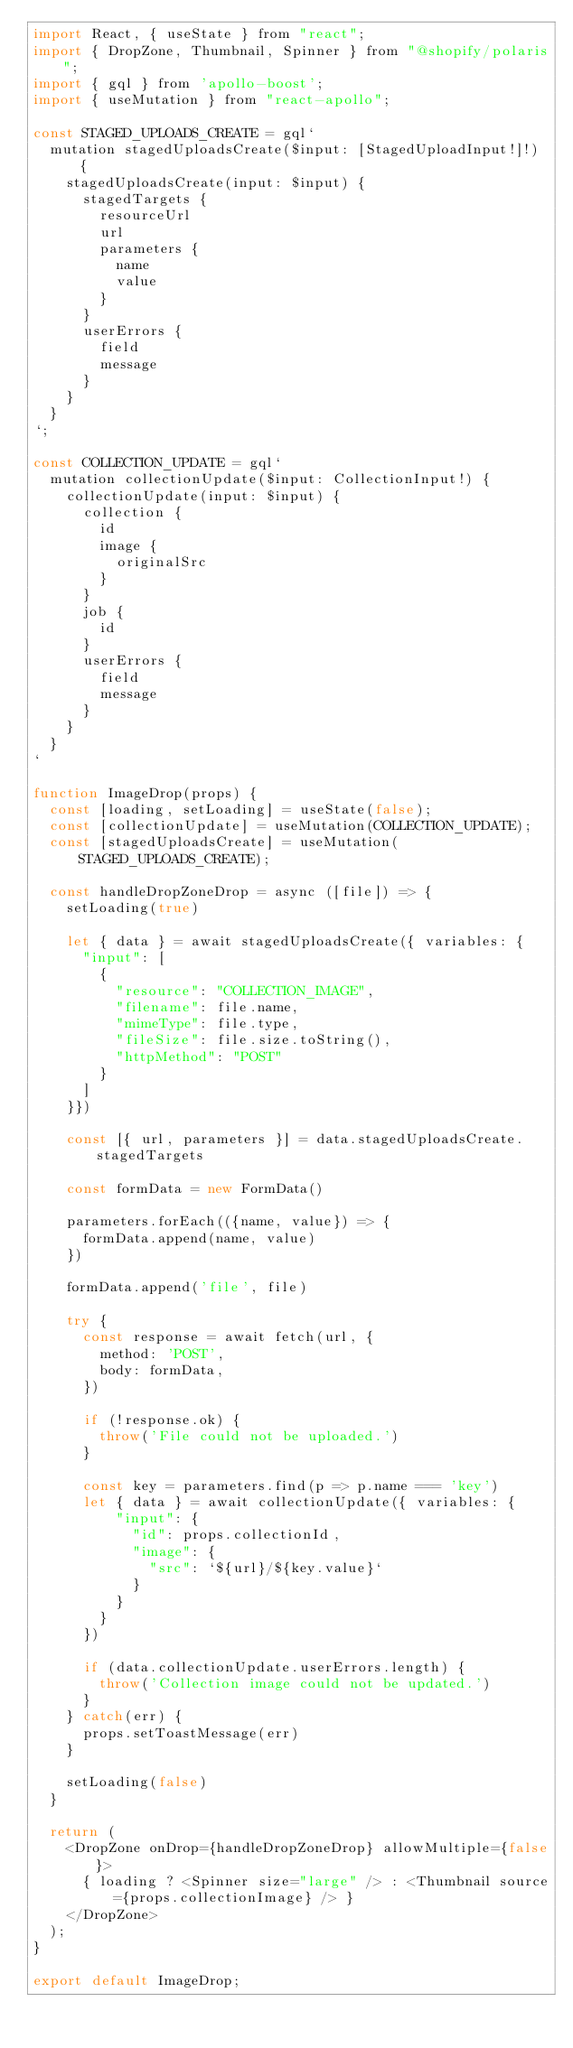Convert code to text. <code><loc_0><loc_0><loc_500><loc_500><_JavaScript_>import React, { useState } from "react";
import { DropZone, Thumbnail, Spinner } from "@shopify/polaris";
import { gql } from 'apollo-boost';
import { useMutation } from "react-apollo";

const STAGED_UPLOADS_CREATE = gql`
  mutation stagedUploadsCreate($input: [StagedUploadInput!]!) {
    stagedUploadsCreate(input: $input) {
      stagedTargets {
        resourceUrl
        url
        parameters {
          name
          value
        }
      }
      userErrors {
        field
        message
      }
    }
  }
`;

const COLLECTION_UPDATE = gql`
  mutation collectionUpdate($input: CollectionInput!) {
    collectionUpdate(input: $input) {
      collection {
        id
        image {
          originalSrc
        }
      }
      job {
        id
      }
      userErrors {
        field
        message
      }
    }
  }
`

function ImageDrop(props) {
  const [loading, setLoading] = useState(false);
  const [collectionUpdate] = useMutation(COLLECTION_UPDATE);
  const [stagedUploadsCreate] = useMutation(STAGED_UPLOADS_CREATE);

  const handleDropZoneDrop = async ([file]) => {
    setLoading(true)

    let { data } = await stagedUploadsCreate({ variables: {
      "input": [
        {
          "resource": "COLLECTION_IMAGE",
          "filename": file.name,
          "mimeType": file.type,
          "fileSize": file.size.toString(),
          "httpMethod": "POST"
        }
      ]
    }})

    const [{ url, parameters }] = data.stagedUploadsCreate.stagedTargets

    const formData = new FormData()

    parameters.forEach(({name, value}) => {
      formData.append(name, value)
    })

    formData.append('file', file)

    try {
      const response = await fetch(url, {
        method: 'POST',
        body: formData,
      })

      if (!response.ok) {
        throw('File could not be uploaded.')
      }

      const key = parameters.find(p => p.name === 'key')
      let { data } = await collectionUpdate({ variables: {
          "input": {
            "id": props.collectionId,
            "image": {
              "src": `${url}/${key.value}`
            }
          }
        }
      })

      if (data.collectionUpdate.userErrors.length) {
        throw('Collection image could not be updated.')
      }
    } catch(err) {
      props.setToastMessage(err)
    }

    setLoading(false)
  }

  return (
    <DropZone onDrop={handleDropZoneDrop} allowMultiple={false}>
      { loading ? <Spinner size="large" /> : <Thumbnail source={props.collectionImage} /> }
    </DropZone>
  );
}

export default ImageDrop;
</code> 